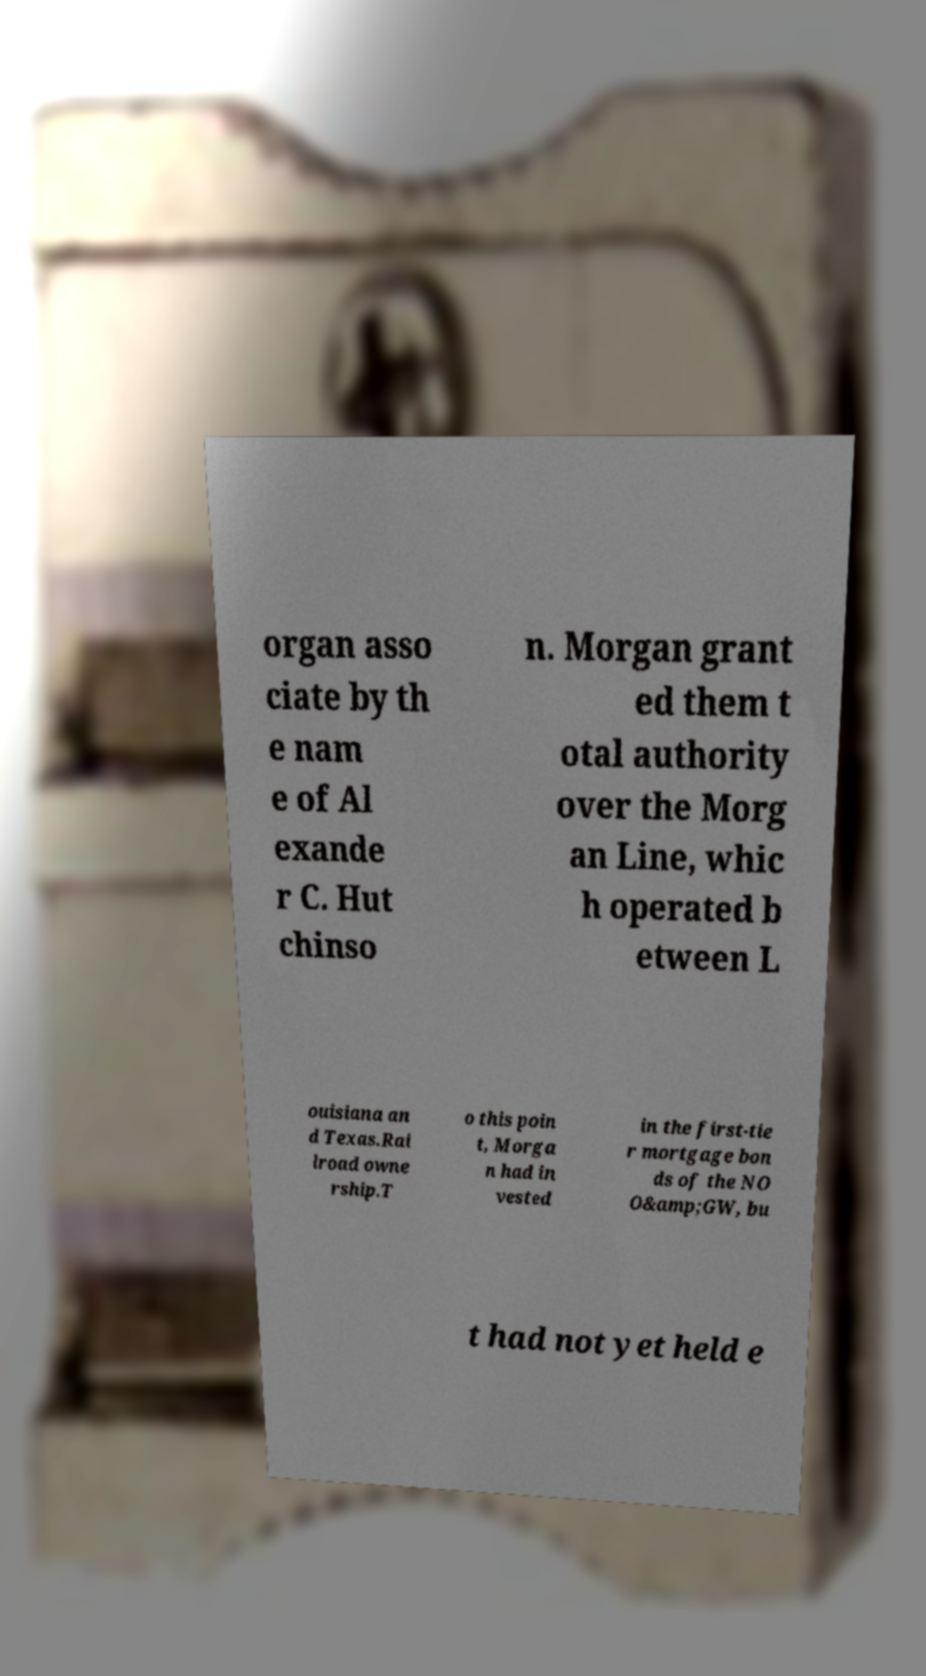Can you read and provide the text displayed in the image?This photo seems to have some interesting text. Can you extract and type it out for me? organ asso ciate by th e nam e of Al exande r C. Hut chinso n. Morgan grant ed them t otal authority over the Morg an Line, whic h operated b etween L ouisiana an d Texas.Rai lroad owne rship.T o this poin t, Morga n had in vested in the first-tie r mortgage bon ds of the NO O&amp;GW, bu t had not yet held e 